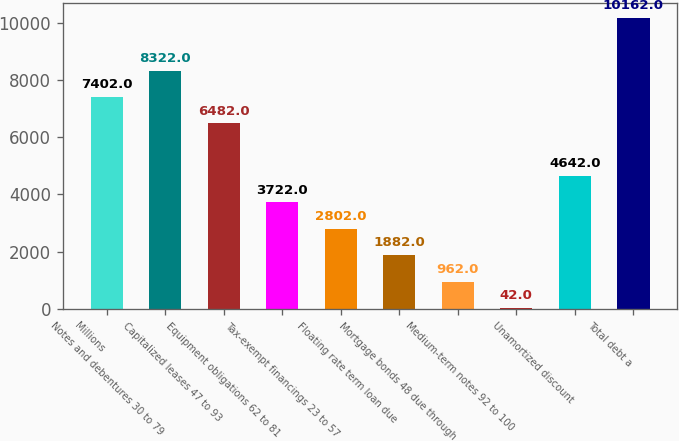Convert chart to OTSL. <chart><loc_0><loc_0><loc_500><loc_500><bar_chart><fcel>Millions<fcel>Notes and debentures 30 to 79<fcel>Capitalized leases 47 to 93<fcel>Equipment obligations 62 to 81<fcel>Tax-exempt financings 23 to 57<fcel>Floating rate term loan due<fcel>Mortgage bonds 48 due through<fcel>Medium-term notes 92 to 100<fcel>Unamortized discount<fcel>Total debt a<nl><fcel>7402<fcel>8322<fcel>6482<fcel>3722<fcel>2802<fcel>1882<fcel>962<fcel>42<fcel>4642<fcel>10162<nl></chart> 